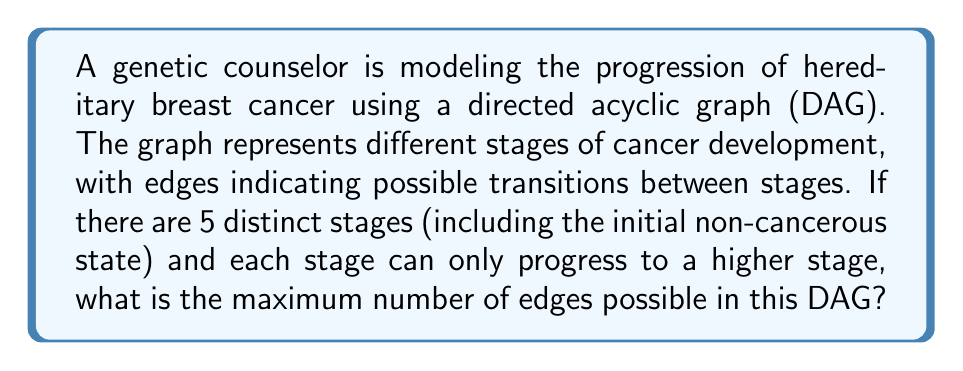Provide a solution to this math problem. Let's approach this step-by-step:

1) In a DAG representing cancer progression, each node represents a stage, and edges represent possible transitions between stages.

2) Given that there are 5 distinct stages and progression can only occur to higher stages, we can number the stages from 0 (initial non-cancerous state) to 4 (most advanced stage).

3) To find the maximum number of edges, we need to consider all possible transitions from lower to higher stages.

4) From stage 0:
   - It can connect to stages 1, 2, 3, and 4 (4 edges)

5) From stage 1:
   - It can connect to stages 2, 3, and 4 (3 edges)

6) From stage 2:
   - It can connect to stages 3 and 4 (2 edges)

7) From stage 3:
   - It can connect to stage 4 (1 edge)

8) From stage 4:
   - No outgoing edges as it's the final stage

9) To calculate the total number of edges, we sum up all possible connections:

   $$ \text{Total edges} = 4 + 3 + 2 + 1 = 10 $$

This can also be represented by the formula for the sum of the first $n-1$ natural numbers, where $n$ is the number of stages:

$$ \text{Maximum edges} = \frac{n(n-1)}{2} = \frac{5(5-1)}{2} = \frac{5 \cdot 4}{2} = 10 $$

Therefore, the maximum number of edges in this DAG is 10.
Answer: 10 edges 